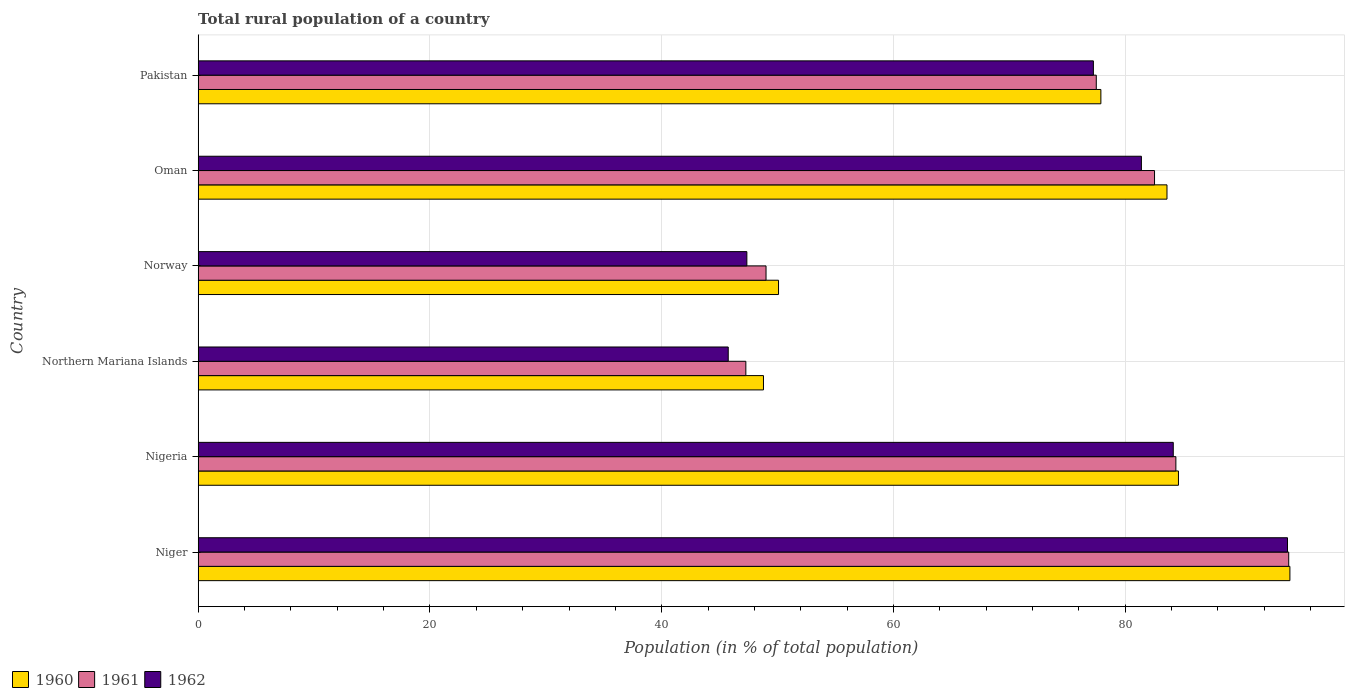How many different coloured bars are there?
Provide a succinct answer. 3. Are the number of bars per tick equal to the number of legend labels?
Ensure brevity in your answer.  Yes. Are the number of bars on each tick of the Y-axis equal?
Ensure brevity in your answer.  Yes. How many bars are there on the 2nd tick from the bottom?
Provide a succinct answer. 3. In how many cases, is the number of bars for a given country not equal to the number of legend labels?
Give a very brief answer. 0. What is the rural population in 1961 in Niger?
Provide a succinct answer. 94.1. Across all countries, what is the maximum rural population in 1960?
Make the answer very short. 94.21. Across all countries, what is the minimum rural population in 1962?
Your answer should be very brief. 45.74. In which country was the rural population in 1960 maximum?
Give a very brief answer. Niger. In which country was the rural population in 1962 minimum?
Offer a very short reply. Northern Mariana Islands. What is the total rural population in 1962 in the graph?
Offer a very short reply. 429.87. What is the difference between the rural population in 1962 in Northern Mariana Islands and that in Norway?
Provide a short and direct response. -1.61. What is the difference between the rural population in 1960 in Northern Mariana Islands and the rural population in 1961 in Nigeria?
Ensure brevity in your answer.  -35.59. What is the average rural population in 1961 per country?
Provide a succinct answer. 72.46. What is the difference between the rural population in 1960 and rural population in 1961 in Northern Mariana Islands?
Make the answer very short. 1.52. In how many countries, is the rural population in 1961 greater than 64 %?
Make the answer very short. 4. What is the ratio of the rural population in 1962 in Niger to that in Nigeria?
Offer a terse response. 1.12. Is the rural population in 1962 in Nigeria less than that in Norway?
Keep it short and to the point. No. What is the difference between the highest and the second highest rural population in 1961?
Your response must be concise. 9.74. What is the difference between the highest and the lowest rural population in 1962?
Your answer should be compact. 48.26. Is the sum of the rural population in 1961 in Norway and Pakistan greater than the maximum rural population in 1960 across all countries?
Provide a short and direct response. Yes. Is it the case that in every country, the sum of the rural population in 1960 and rural population in 1962 is greater than the rural population in 1961?
Ensure brevity in your answer.  Yes. Are all the bars in the graph horizontal?
Make the answer very short. Yes. How many countries are there in the graph?
Your answer should be very brief. 6. Does the graph contain any zero values?
Give a very brief answer. No. How are the legend labels stacked?
Your response must be concise. Horizontal. What is the title of the graph?
Offer a terse response. Total rural population of a country. What is the label or title of the X-axis?
Keep it short and to the point. Population (in % of total population). What is the label or title of the Y-axis?
Offer a terse response. Country. What is the Population (in % of total population) in 1960 in Niger?
Your answer should be compact. 94.21. What is the Population (in % of total population) of 1961 in Niger?
Your answer should be very brief. 94.1. What is the Population (in % of total population) in 1962 in Niger?
Give a very brief answer. 94. What is the Population (in % of total population) in 1960 in Nigeria?
Your answer should be very brief. 84.59. What is the Population (in % of total population) of 1961 in Nigeria?
Your answer should be very brief. 84.37. What is the Population (in % of total population) of 1962 in Nigeria?
Make the answer very short. 84.14. What is the Population (in % of total population) of 1960 in Northern Mariana Islands?
Offer a very short reply. 48.78. What is the Population (in % of total population) in 1961 in Northern Mariana Islands?
Give a very brief answer. 47.26. What is the Population (in % of total population) in 1962 in Northern Mariana Islands?
Ensure brevity in your answer.  45.74. What is the Population (in % of total population) in 1960 in Norway?
Your answer should be very brief. 50.08. What is the Population (in % of total population) in 1961 in Norway?
Your answer should be very brief. 49. What is the Population (in % of total population) of 1962 in Norway?
Offer a terse response. 47.35. What is the Population (in % of total population) of 1960 in Oman?
Offer a terse response. 83.6. What is the Population (in % of total population) of 1961 in Oman?
Your response must be concise. 82.53. What is the Population (in % of total population) in 1962 in Oman?
Your answer should be compact. 81.39. What is the Population (in % of total population) of 1960 in Pakistan?
Ensure brevity in your answer.  77.9. What is the Population (in % of total population) of 1961 in Pakistan?
Ensure brevity in your answer.  77.5. What is the Population (in % of total population) in 1962 in Pakistan?
Provide a short and direct response. 77.25. Across all countries, what is the maximum Population (in % of total population) of 1960?
Your response must be concise. 94.21. Across all countries, what is the maximum Population (in % of total population) of 1961?
Your answer should be very brief. 94.1. Across all countries, what is the maximum Population (in % of total population) in 1962?
Keep it short and to the point. 94. Across all countries, what is the minimum Population (in % of total population) of 1960?
Offer a terse response. 48.78. Across all countries, what is the minimum Population (in % of total population) in 1961?
Provide a short and direct response. 47.26. Across all countries, what is the minimum Population (in % of total population) in 1962?
Make the answer very short. 45.74. What is the total Population (in % of total population) of 1960 in the graph?
Your answer should be very brief. 439.15. What is the total Population (in % of total population) in 1961 in the graph?
Make the answer very short. 434.76. What is the total Population (in % of total population) of 1962 in the graph?
Your answer should be very brief. 429.87. What is the difference between the Population (in % of total population) in 1960 in Niger and that in Nigeria?
Give a very brief answer. 9.62. What is the difference between the Population (in % of total population) in 1961 in Niger and that in Nigeria?
Give a very brief answer. 9.74. What is the difference between the Population (in % of total population) in 1962 in Niger and that in Nigeria?
Ensure brevity in your answer.  9.86. What is the difference between the Population (in % of total population) in 1960 in Niger and that in Northern Mariana Islands?
Your answer should be compact. 45.43. What is the difference between the Population (in % of total population) in 1961 in Niger and that in Northern Mariana Islands?
Ensure brevity in your answer.  46.84. What is the difference between the Population (in % of total population) of 1962 in Niger and that in Northern Mariana Islands?
Make the answer very short. 48.26. What is the difference between the Population (in % of total population) of 1960 in Niger and that in Norway?
Offer a very short reply. 44.13. What is the difference between the Population (in % of total population) in 1961 in Niger and that in Norway?
Keep it short and to the point. 45.1. What is the difference between the Population (in % of total population) of 1962 in Niger and that in Norway?
Offer a terse response. 46.65. What is the difference between the Population (in % of total population) in 1960 in Niger and that in Oman?
Your answer should be compact. 10.61. What is the difference between the Population (in % of total population) of 1961 in Niger and that in Oman?
Provide a short and direct response. 11.58. What is the difference between the Population (in % of total population) of 1962 in Niger and that in Oman?
Your answer should be compact. 12.61. What is the difference between the Population (in % of total population) of 1960 in Niger and that in Pakistan?
Offer a terse response. 16.31. What is the difference between the Population (in % of total population) of 1961 in Niger and that in Pakistan?
Give a very brief answer. 16.61. What is the difference between the Population (in % of total population) of 1962 in Niger and that in Pakistan?
Provide a short and direct response. 16.75. What is the difference between the Population (in % of total population) of 1960 in Nigeria and that in Northern Mariana Islands?
Offer a very short reply. 35.81. What is the difference between the Population (in % of total population) of 1961 in Nigeria and that in Northern Mariana Islands?
Provide a succinct answer. 37.11. What is the difference between the Population (in % of total population) in 1962 in Nigeria and that in Northern Mariana Islands?
Offer a very short reply. 38.4. What is the difference between the Population (in % of total population) in 1960 in Nigeria and that in Norway?
Give a very brief answer. 34.51. What is the difference between the Population (in % of total population) of 1961 in Nigeria and that in Norway?
Offer a terse response. 35.37. What is the difference between the Population (in % of total population) of 1962 in Nigeria and that in Norway?
Your answer should be very brief. 36.8. What is the difference between the Population (in % of total population) in 1960 in Nigeria and that in Oman?
Make the answer very short. 0.99. What is the difference between the Population (in % of total population) in 1961 in Nigeria and that in Oman?
Ensure brevity in your answer.  1.84. What is the difference between the Population (in % of total population) of 1962 in Nigeria and that in Oman?
Your answer should be compact. 2.75. What is the difference between the Population (in % of total population) of 1960 in Nigeria and that in Pakistan?
Give a very brief answer. 6.69. What is the difference between the Population (in % of total population) of 1961 in Nigeria and that in Pakistan?
Ensure brevity in your answer.  6.87. What is the difference between the Population (in % of total population) in 1962 in Nigeria and that in Pakistan?
Ensure brevity in your answer.  6.89. What is the difference between the Population (in % of total population) of 1960 in Northern Mariana Islands and that in Norway?
Provide a short and direct response. -1.3. What is the difference between the Population (in % of total population) in 1961 in Northern Mariana Islands and that in Norway?
Keep it short and to the point. -1.74. What is the difference between the Population (in % of total population) of 1962 in Northern Mariana Islands and that in Norway?
Make the answer very short. -1.61. What is the difference between the Population (in % of total population) of 1960 in Northern Mariana Islands and that in Oman?
Offer a very short reply. -34.82. What is the difference between the Population (in % of total population) of 1961 in Northern Mariana Islands and that in Oman?
Make the answer very short. -35.27. What is the difference between the Population (in % of total population) of 1962 in Northern Mariana Islands and that in Oman?
Keep it short and to the point. -35.65. What is the difference between the Population (in % of total population) in 1960 in Northern Mariana Islands and that in Pakistan?
Give a very brief answer. -29.11. What is the difference between the Population (in % of total population) in 1961 in Northern Mariana Islands and that in Pakistan?
Provide a short and direct response. -30.24. What is the difference between the Population (in % of total population) in 1962 in Northern Mariana Islands and that in Pakistan?
Provide a short and direct response. -31.51. What is the difference between the Population (in % of total population) of 1960 in Norway and that in Oman?
Ensure brevity in your answer.  -33.52. What is the difference between the Population (in % of total population) of 1961 in Norway and that in Oman?
Provide a short and direct response. -33.52. What is the difference between the Population (in % of total population) in 1962 in Norway and that in Oman?
Your answer should be compact. -34.05. What is the difference between the Population (in % of total population) of 1960 in Norway and that in Pakistan?
Your response must be concise. -27.82. What is the difference between the Population (in % of total population) in 1961 in Norway and that in Pakistan?
Provide a succinct answer. -28.5. What is the difference between the Population (in % of total population) of 1962 in Norway and that in Pakistan?
Your answer should be very brief. -29.9. What is the difference between the Population (in % of total population) in 1960 in Oman and that in Pakistan?
Give a very brief answer. 5.7. What is the difference between the Population (in % of total population) in 1961 in Oman and that in Pakistan?
Provide a succinct answer. 5.03. What is the difference between the Population (in % of total population) of 1962 in Oman and that in Pakistan?
Ensure brevity in your answer.  4.14. What is the difference between the Population (in % of total population) of 1960 in Niger and the Population (in % of total population) of 1961 in Nigeria?
Offer a terse response. 9.84. What is the difference between the Population (in % of total population) of 1960 in Niger and the Population (in % of total population) of 1962 in Nigeria?
Your response must be concise. 10.06. What is the difference between the Population (in % of total population) of 1961 in Niger and the Population (in % of total population) of 1962 in Nigeria?
Your response must be concise. 9.96. What is the difference between the Population (in % of total population) in 1960 in Niger and the Population (in % of total population) in 1961 in Northern Mariana Islands?
Offer a very short reply. 46.95. What is the difference between the Population (in % of total population) of 1960 in Niger and the Population (in % of total population) of 1962 in Northern Mariana Islands?
Your answer should be very brief. 48.47. What is the difference between the Population (in % of total population) in 1961 in Niger and the Population (in % of total population) in 1962 in Northern Mariana Islands?
Offer a terse response. 48.36. What is the difference between the Population (in % of total population) of 1960 in Niger and the Population (in % of total population) of 1961 in Norway?
Your answer should be very brief. 45.2. What is the difference between the Population (in % of total population) in 1960 in Niger and the Population (in % of total population) in 1962 in Norway?
Offer a very short reply. 46.86. What is the difference between the Population (in % of total population) of 1961 in Niger and the Population (in % of total population) of 1962 in Norway?
Offer a very short reply. 46.76. What is the difference between the Population (in % of total population) in 1960 in Niger and the Population (in % of total population) in 1961 in Oman?
Offer a very short reply. 11.68. What is the difference between the Population (in % of total population) of 1960 in Niger and the Population (in % of total population) of 1962 in Oman?
Offer a very short reply. 12.81. What is the difference between the Population (in % of total population) in 1961 in Niger and the Population (in % of total population) in 1962 in Oman?
Make the answer very short. 12.71. What is the difference between the Population (in % of total population) of 1960 in Niger and the Population (in % of total population) of 1961 in Pakistan?
Make the answer very short. 16.71. What is the difference between the Population (in % of total population) of 1960 in Niger and the Population (in % of total population) of 1962 in Pakistan?
Your answer should be very brief. 16.96. What is the difference between the Population (in % of total population) in 1961 in Niger and the Population (in % of total population) in 1962 in Pakistan?
Ensure brevity in your answer.  16.86. What is the difference between the Population (in % of total population) of 1960 in Nigeria and the Population (in % of total population) of 1961 in Northern Mariana Islands?
Offer a terse response. 37.33. What is the difference between the Population (in % of total population) in 1960 in Nigeria and the Population (in % of total population) in 1962 in Northern Mariana Islands?
Make the answer very short. 38.85. What is the difference between the Population (in % of total population) in 1961 in Nigeria and the Population (in % of total population) in 1962 in Northern Mariana Islands?
Your answer should be very brief. 38.63. What is the difference between the Population (in % of total population) of 1960 in Nigeria and the Population (in % of total population) of 1961 in Norway?
Your response must be concise. 35.59. What is the difference between the Population (in % of total population) in 1960 in Nigeria and the Population (in % of total population) in 1962 in Norway?
Offer a terse response. 37.24. What is the difference between the Population (in % of total population) of 1961 in Nigeria and the Population (in % of total population) of 1962 in Norway?
Provide a succinct answer. 37.02. What is the difference between the Population (in % of total population) in 1960 in Nigeria and the Population (in % of total population) in 1961 in Oman?
Your response must be concise. 2.06. What is the difference between the Population (in % of total population) in 1960 in Nigeria and the Population (in % of total population) in 1962 in Oman?
Provide a short and direct response. 3.2. What is the difference between the Population (in % of total population) of 1961 in Nigeria and the Population (in % of total population) of 1962 in Oman?
Ensure brevity in your answer.  2.97. What is the difference between the Population (in % of total population) of 1960 in Nigeria and the Population (in % of total population) of 1961 in Pakistan?
Ensure brevity in your answer.  7.09. What is the difference between the Population (in % of total population) in 1960 in Nigeria and the Population (in % of total population) in 1962 in Pakistan?
Provide a short and direct response. 7.34. What is the difference between the Population (in % of total population) in 1961 in Nigeria and the Population (in % of total population) in 1962 in Pakistan?
Make the answer very short. 7.12. What is the difference between the Population (in % of total population) of 1960 in Northern Mariana Islands and the Population (in % of total population) of 1961 in Norway?
Keep it short and to the point. -0.22. What is the difference between the Population (in % of total population) of 1960 in Northern Mariana Islands and the Population (in % of total population) of 1962 in Norway?
Make the answer very short. 1.43. What is the difference between the Population (in % of total population) in 1961 in Northern Mariana Islands and the Population (in % of total population) in 1962 in Norway?
Keep it short and to the point. -0.09. What is the difference between the Population (in % of total population) of 1960 in Northern Mariana Islands and the Population (in % of total population) of 1961 in Oman?
Make the answer very short. -33.74. What is the difference between the Population (in % of total population) in 1960 in Northern Mariana Islands and the Population (in % of total population) in 1962 in Oman?
Offer a very short reply. -32.61. What is the difference between the Population (in % of total population) of 1961 in Northern Mariana Islands and the Population (in % of total population) of 1962 in Oman?
Your answer should be very brief. -34.13. What is the difference between the Population (in % of total population) of 1960 in Northern Mariana Islands and the Population (in % of total population) of 1961 in Pakistan?
Make the answer very short. -28.72. What is the difference between the Population (in % of total population) in 1960 in Northern Mariana Islands and the Population (in % of total population) in 1962 in Pakistan?
Provide a succinct answer. -28.47. What is the difference between the Population (in % of total population) in 1961 in Northern Mariana Islands and the Population (in % of total population) in 1962 in Pakistan?
Your response must be concise. -29.99. What is the difference between the Population (in % of total population) in 1960 in Norway and the Population (in % of total population) in 1961 in Oman?
Provide a short and direct response. -32.45. What is the difference between the Population (in % of total population) in 1960 in Norway and the Population (in % of total population) in 1962 in Oman?
Your answer should be compact. -31.31. What is the difference between the Population (in % of total population) in 1961 in Norway and the Population (in % of total population) in 1962 in Oman?
Make the answer very short. -32.39. What is the difference between the Population (in % of total population) of 1960 in Norway and the Population (in % of total population) of 1961 in Pakistan?
Ensure brevity in your answer.  -27.42. What is the difference between the Population (in % of total population) of 1960 in Norway and the Population (in % of total population) of 1962 in Pakistan?
Offer a very short reply. -27.17. What is the difference between the Population (in % of total population) of 1961 in Norway and the Population (in % of total population) of 1962 in Pakistan?
Keep it short and to the point. -28.25. What is the difference between the Population (in % of total population) in 1960 in Oman and the Population (in % of total population) in 1961 in Pakistan?
Make the answer very short. 6.1. What is the difference between the Population (in % of total population) of 1960 in Oman and the Population (in % of total population) of 1962 in Pakistan?
Provide a succinct answer. 6.35. What is the difference between the Population (in % of total population) of 1961 in Oman and the Population (in % of total population) of 1962 in Pakistan?
Make the answer very short. 5.28. What is the average Population (in % of total population) of 1960 per country?
Provide a succinct answer. 73.19. What is the average Population (in % of total population) of 1961 per country?
Keep it short and to the point. 72.46. What is the average Population (in % of total population) in 1962 per country?
Offer a very short reply. 71.65. What is the difference between the Population (in % of total population) of 1960 and Population (in % of total population) of 1961 in Niger?
Keep it short and to the point. 0.1. What is the difference between the Population (in % of total population) of 1960 and Population (in % of total population) of 1962 in Niger?
Your response must be concise. 0.21. What is the difference between the Population (in % of total population) of 1961 and Population (in % of total population) of 1962 in Niger?
Give a very brief answer. 0.1. What is the difference between the Population (in % of total population) of 1960 and Population (in % of total population) of 1961 in Nigeria?
Your answer should be compact. 0.22. What is the difference between the Population (in % of total population) of 1960 and Population (in % of total population) of 1962 in Nigeria?
Your response must be concise. 0.45. What is the difference between the Population (in % of total population) of 1961 and Population (in % of total population) of 1962 in Nigeria?
Your answer should be very brief. 0.23. What is the difference between the Population (in % of total population) of 1960 and Population (in % of total population) of 1961 in Northern Mariana Islands?
Keep it short and to the point. 1.52. What is the difference between the Population (in % of total population) of 1960 and Population (in % of total population) of 1962 in Northern Mariana Islands?
Keep it short and to the point. 3.04. What is the difference between the Population (in % of total population) of 1961 and Population (in % of total population) of 1962 in Northern Mariana Islands?
Offer a terse response. 1.52. What is the difference between the Population (in % of total population) in 1960 and Population (in % of total population) in 1961 in Norway?
Offer a terse response. 1.08. What is the difference between the Population (in % of total population) in 1960 and Population (in % of total population) in 1962 in Norway?
Your response must be concise. 2.73. What is the difference between the Population (in % of total population) in 1961 and Population (in % of total population) in 1962 in Norway?
Ensure brevity in your answer.  1.66. What is the difference between the Population (in % of total population) in 1960 and Population (in % of total population) in 1961 in Oman?
Offer a terse response. 1.07. What is the difference between the Population (in % of total population) in 1960 and Population (in % of total population) in 1962 in Oman?
Keep it short and to the point. 2.21. What is the difference between the Population (in % of total population) in 1961 and Population (in % of total population) in 1962 in Oman?
Make the answer very short. 1.13. What is the difference between the Population (in % of total population) of 1960 and Population (in % of total population) of 1961 in Pakistan?
Your response must be concise. 0.4. What is the difference between the Population (in % of total population) of 1960 and Population (in % of total population) of 1962 in Pakistan?
Offer a terse response. 0.65. What is the difference between the Population (in % of total population) of 1961 and Population (in % of total population) of 1962 in Pakistan?
Provide a succinct answer. 0.25. What is the ratio of the Population (in % of total population) of 1960 in Niger to that in Nigeria?
Offer a terse response. 1.11. What is the ratio of the Population (in % of total population) of 1961 in Niger to that in Nigeria?
Offer a terse response. 1.12. What is the ratio of the Population (in % of total population) of 1962 in Niger to that in Nigeria?
Your answer should be very brief. 1.12. What is the ratio of the Population (in % of total population) in 1960 in Niger to that in Northern Mariana Islands?
Ensure brevity in your answer.  1.93. What is the ratio of the Population (in % of total population) of 1961 in Niger to that in Northern Mariana Islands?
Offer a terse response. 1.99. What is the ratio of the Population (in % of total population) in 1962 in Niger to that in Northern Mariana Islands?
Provide a succinct answer. 2.06. What is the ratio of the Population (in % of total population) of 1960 in Niger to that in Norway?
Your answer should be very brief. 1.88. What is the ratio of the Population (in % of total population) in 1961 in Niger to that in Norway?
Offer a very short reply. 1.92. What is the ratio of the Population (in % of total population) of 1962 in Niger to that in Norway?
Your answer should be very brief. 1.99. What is the ratio of the Population (in % of total population) of 1960 in Niger to that in Oman?
Provide a succinct answer. 1.13. What is the ratio of the Population (in % of total population) of 1961 in Niger to that in Oman?
Provide a short and direct response. 1.14. What is the ratio of the Population (in % of total population) in 1962 in Niger to that in Oman?
Keep it short and to the point. 1.15. What is the ratio of the Population (in % of total population) in 1960 in Niger to that in Pakistan?
Ensure brevity in your answer.  1.21. What is the ratio of the Population (in % of total population) of 1961 in Niger to that in Pakistan?
Your answer should be very brief. 1.21. What is the ratio of the Population (in % of total population) of 1962 in Niger to that in Pakistan?
Provide a short and direct response. 1.22. What is the ratio of the Population (in % of total population) in 1960 in Nigeria to that in Northern Mariana Islands?
Provide a succinct answer. 1.73. What is the ratio of the Population (in % of total population) of 1961 in Nigeria to that in Northern Mariana Islands?
Keep it short and to the point. 1.79. What is the ratio of the Population (in % of total population) in 1962 in Nigeria to that in Northern Mariana Islands?
Give a very brief answer. 1.84. What is the ratio of the Population (in % of total population) of 1960 in Nigeria to that in Norway?
Give a very brief answer. 1.69. What is the ratio of the Population (in % of total population) of 1961 in Nigeria to that in Norway?
Your answer should be compact. 1.72. What is the ratio of the Population (in % of total population) in 1962 in Nigeria to that in Norway?
Offer a terse response. 1.78. What is the ratio of the Population (in % of total population) of 1960 in Nigeria to that in Oman?
Ensure brevity in your answer.  1.01. What is the ratio of the Population (in % of total population) in 1961 in Nigeria to that in Oman?
Your answer should be very brief. 1.02. What is the ratio of the Population (in % of total population) in 1962 in Nigeria to that in Oman?
Your answer should be very brief. 1.03. What is the ratio of the Population (in % of total population) in 1960 in Nigeria to that in Pakistan?
Keep it short and to the point. 1.09. What is the ratio of the Population (in % of total population) in 1961 in Nigeria to that in Pakistan?
Your answer should be compact. 1.09. What is the ratio of the Population (in % of total population) of 1962 in Nigeria to that in Pakistan?
Give a very brief answer. 1.09. What is the ratio of the Population (in % of total population) in 1960 in Northern Mariana Islands to that in Norway?
Provide a succinct answer. 0.97. What is the ratio of the Population (in % of total population) of 1961 in Northern Mariana Islands to that in Norway?
Your response must be concise. 0.96. What is the ratio of the Population (in % of total population) of 1962 in Northern Mariana Islands to that in Norway?
Your answer should be compact. 0.97. What is the ratio of the Population (in % of total population) in 1960 in Northern Mariana Islands to that in Oman?
Your answer should be compact. 0.58. What is the ratio of the Population (in % of total population) of 1961 in Northern Mariana Islands to that in Oman?
Give a very brief answer. 0.57. What is the ratio of the Population (in % of total population) of 1962 in Northern Mariana Islands to that in Oman?
Your answer should be compact. 0.56. What is the ratio of the Population (in % of total population) of 1960 in Northern Mariana Islands to that in Pakistan?
Provide a succinct answer. 0.63. What is the ratio of the Population (in % of total population) in 1961 in Northern Mariana Islands to that in Pakistan?
Keep it short and to the point. 0.61. What is the ratio of the Population (in % of total population) of 1962 in Northern Mariana Islands to that in Pakistan?
Make the answer very short. 0.59. What is the ratio of the Population (in % of total population) of 1960 in Norway to that in Oman?
Ensure brevity in your answer.  0.6. What is the ratio of the Population (in % of total population) in 1961 in Norway to that in Oman?
Offer a very short reply. 0.59. What is the ratio of the Population (in % of total population) in 1962 in Norway to that in Oman?
Ensure brevity in your answer.  0.58. What is the ratio of the Population (in % of total population) in 1960 in Norway to that in Pakistan?
Make the answer very short. 0.64. What is the ratio of the Population (in % of total population) of 1961 in Norway to that in Pakistan?
Keep it short and to the point. 0.63. What is the ratio of the Population (in % of total population) of 1962 in Norway to that in Pakistan?
Your answer should be compact. 0.61. What is the ratio of the Population (in % of total population) in 1960 in Oman to that in Pakistan?
Give a very brief answer. 1.07. What is the ratio of the Population (in % of total population) in 1961 in Oman to that in Pakistan?
Keep it short and to the point. 1.06. What is the ratio of the Population (in % of total population) in 1962 in Oman to that in Pakistan?
Give a very brief answer. 1.05. What is the difference between the highest and the second highest Population (in % of total population) in 1960?
Provide a succinct answer. 9.62. What is the difference between the highest and the second highest Population (in % of total population) in 1961?
Your answer should be very brief. 9.74. What is the difference between the highest and the second highest Population (in % of total population) of 1962?
Provide a succinct answer. 9.86. What is the difference between the highest and the lowest Population (in % of total population) of 1960?
Ensure brevity in your answer.  45.43. What is the difference between the highest and the lowest Population (in % of total population) in 1961?
Your answer should be very brief. 46.84. What is the difference between the highest and the lowest Population (in % of total population) of 1962?
Provide a short and direct response. 48.26. 